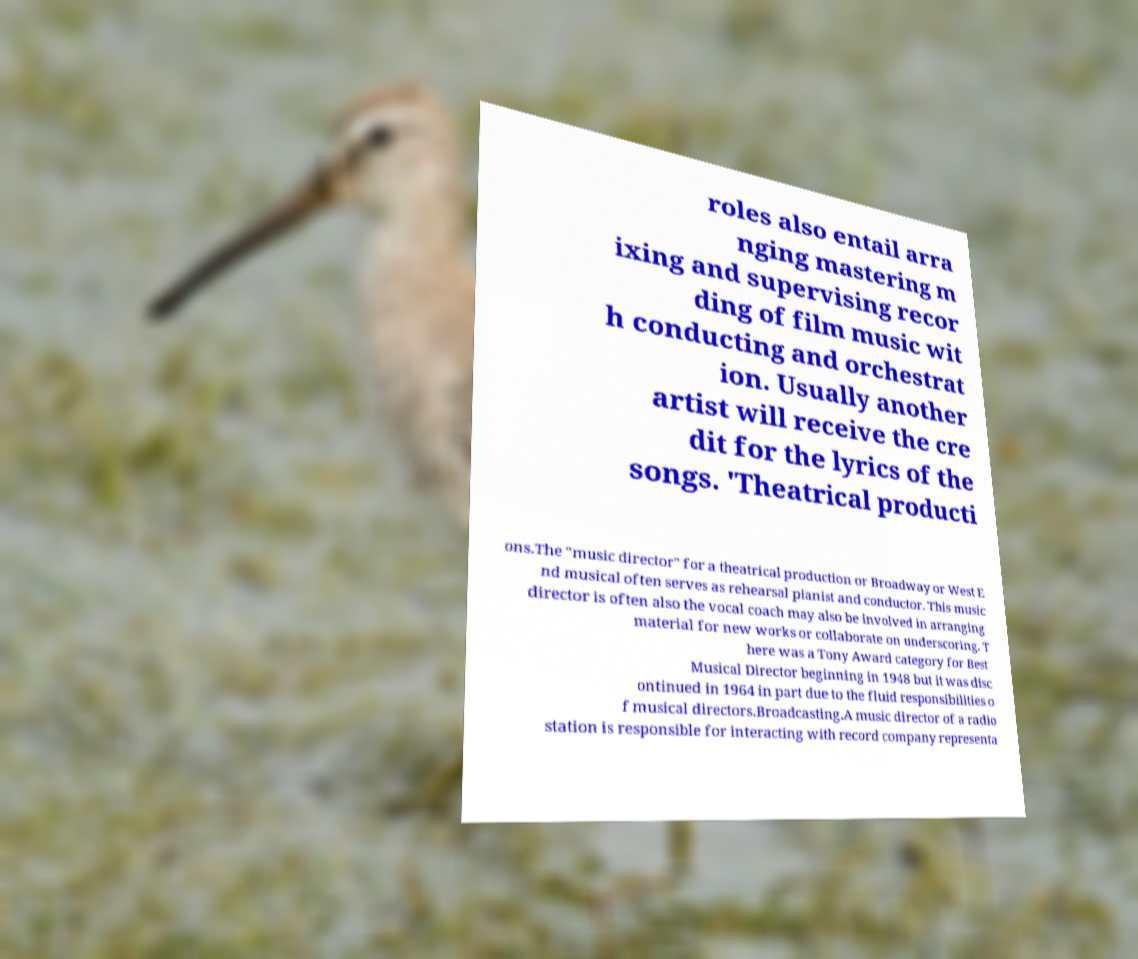Could you assist in decoding the text presented in this image and type it out clearly? roles also entail arra nging mastering m ixing and supervising recor ding of film music wit h conducting and orchestrat ion. Usually another artist will receive the cre dit for the lyrics of the songs. 'Theatrical producti ons.The "music director" for a theatrical production or Broadway or West E nd musical often serves as rehearsal pianist and conductor. This music director is often also the vocal coach may also be involved in arranging material for new works or collaborate on underscoring. T here was a Tony Award category for Best Musical Director beginning in 1948 but it was disc ontinued in 1964 in part due to the fluid responsibilities o f musical directors.Broadcasting.A music director of a radio station is responsible for interacting with record company representa 